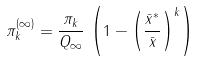<formula> <loc_0><loc_0><loc_500><loc_500>\pi ^ { ( \infty ) } _ { k } = \frac { \pi _ { k } } { Q _ { \infty } } \, \left ( 1 - \left ( \frac { \bar { x } ^ { * } } { \bar { x } } \right ) ^ { k } \right )</formula> 